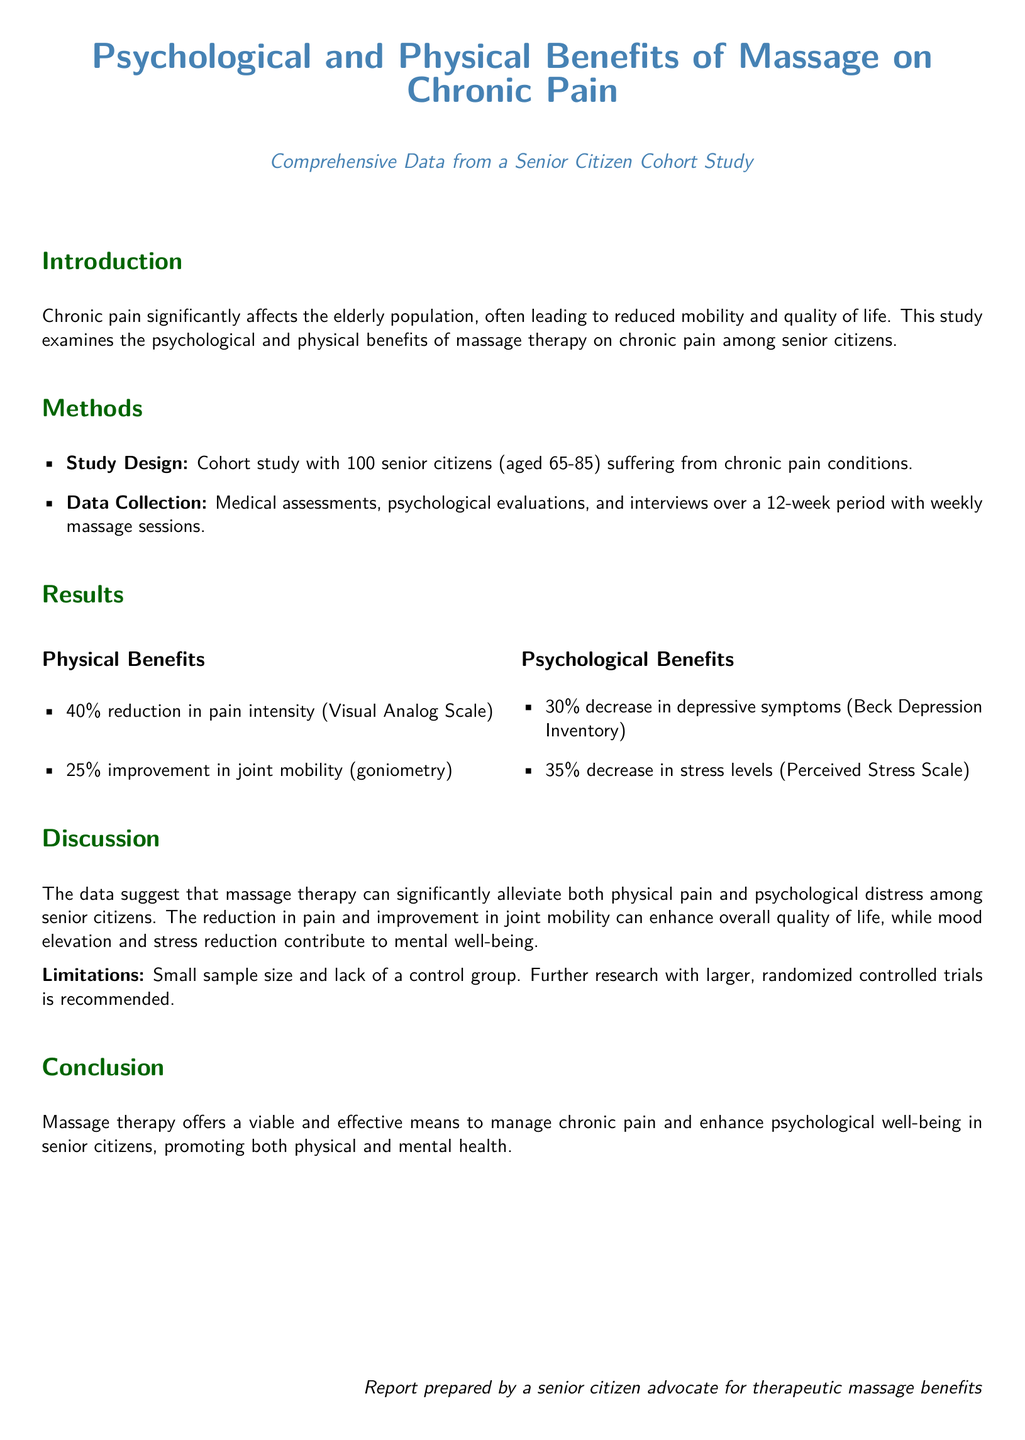what was the age range of participants? The age range of participants in the study was specified as 65-85 years.
Answer: 65-85 how many percent reduction in pain intensity was reported? The report indicates a 40% reduction in pain intensity as per the Visual Analog Scale.
Answer: 40% what tool was used to assess psychological benefits? The Beck Depression Inventory was used to measure the psychological benefits in the study.
Answer: Beck Depression Inventory what was the improvement percentage in joint mobility? The report mentions a 25% improvement in joint mobility measured by goniometry.
Answer: 25% what was the sample size of the study? The study was conducted with a total of 100 senior citizens.
Answer: 100 which psychological benefit had a higher percentage decrease? A 35% decrease in stress levels was reported, which is higher than the 30% decrease in depressive symptoms.
Answer: stress levels what is stated as a limitation of the study? One limitation mentioned is the small sample size and lack of a control group.
Answer: small sample size and lack of a control group what aspect of health does massage therapy promote according to the conclusion? The conclusion states that massage therapy promotes both physical and mental health.
Answer: physical and mental health how long did the massage sessions last for? The massage sessions took place over a 12-week period.
Answer: 12-week period 